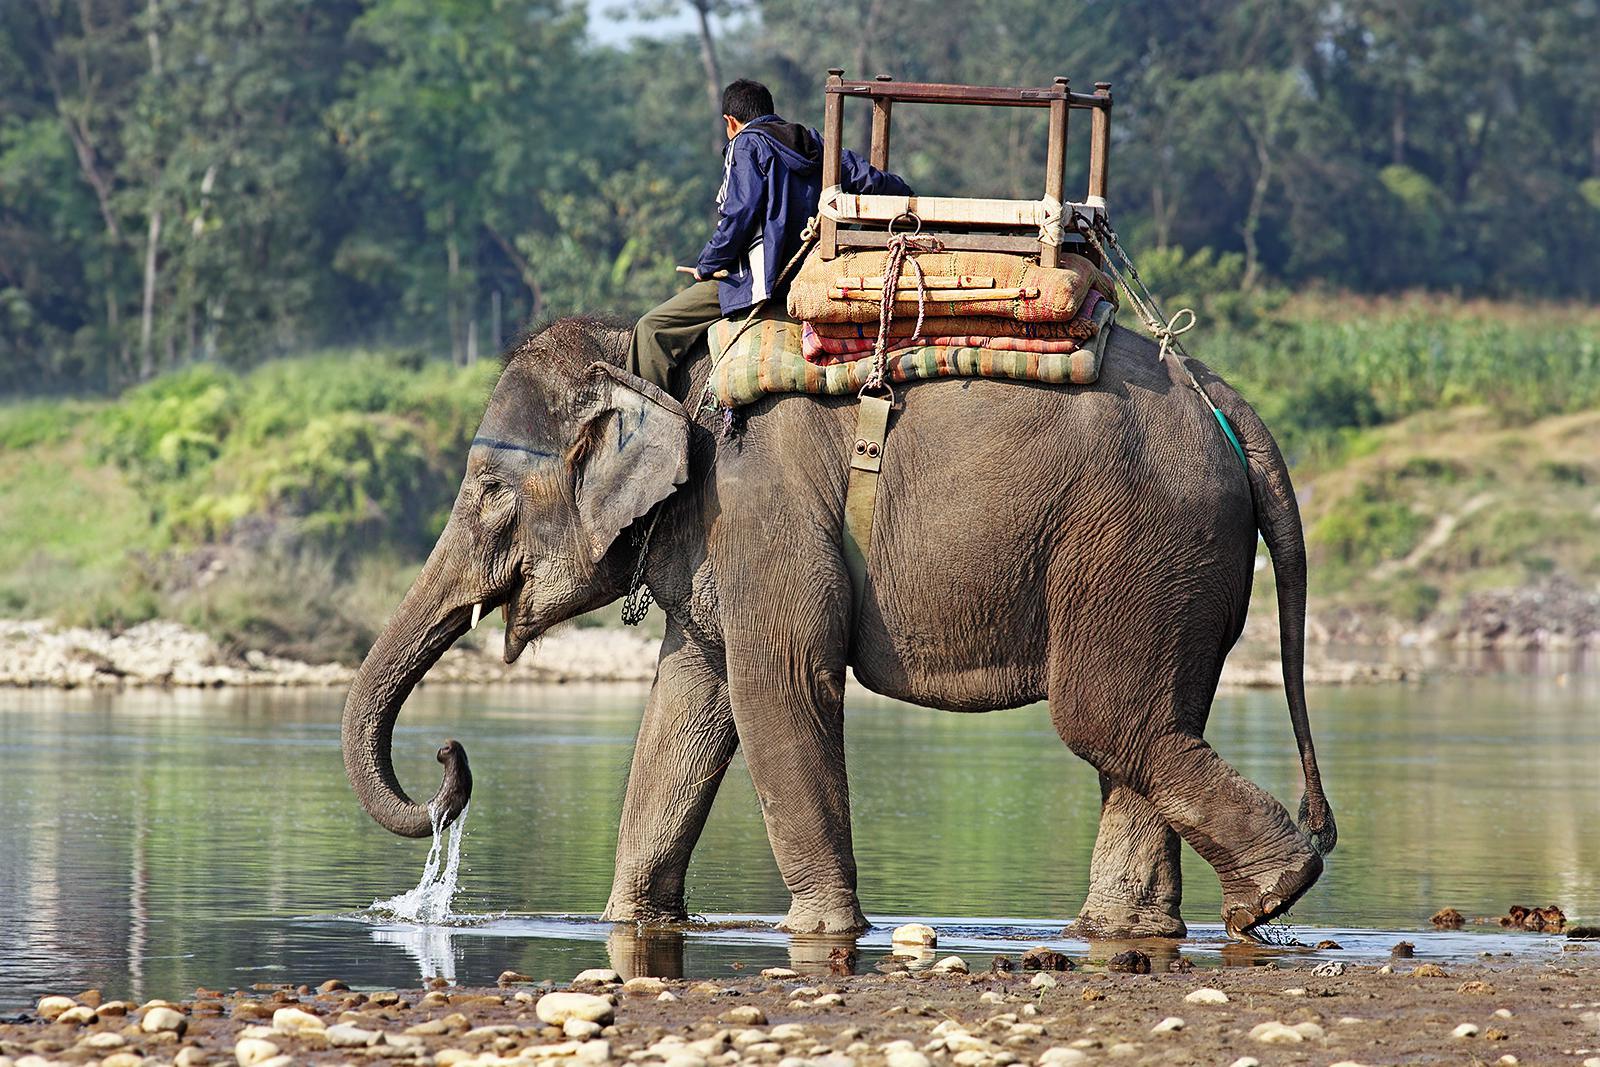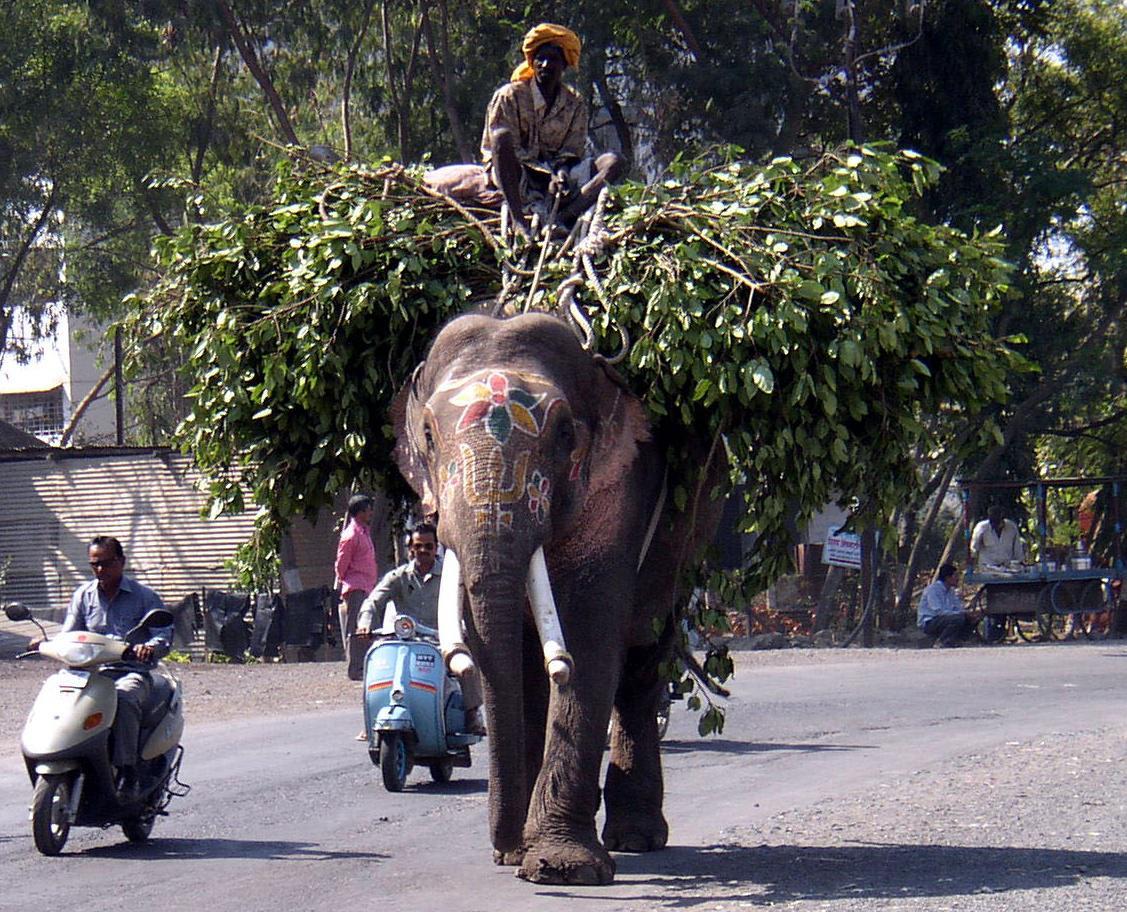The first image is the image on the left, the second image is the image on the right. For the images shown, is this caption "An image shows a camera-facing tusked elephant wearing an ornate dimensional metallic-look head covering." true? Answer yes or no. No. 